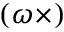Convert formula to latex. <formula><loc_0><loc_0><loc_500><loc_500>( { \omega } \times )</formula> 